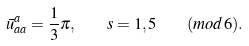Convert formula to latex. <formula><loc_0><loc_0><loc_500><loc_500>\bar { u } _ { a a } ^ { a } = \frac { 1 } { 3 } \pi , \quad s = 1 , 5 \quad ( m o d \, 6 ) .</formula> 